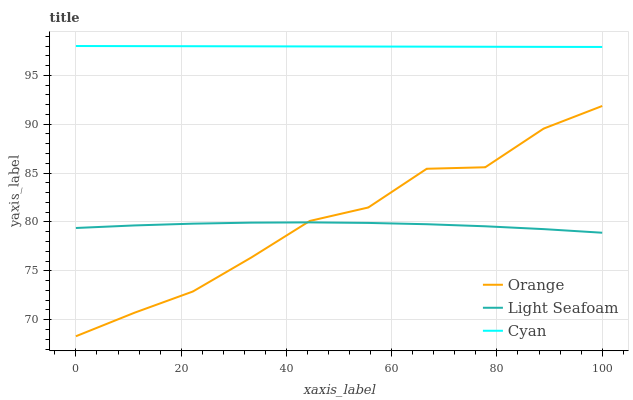Does Light Seafoam have the minimum area under the curve?
Answer yes or no. Yes. Does Cyan have the maximum area under the curve?
Answer yes or no. Yes. Does Cyan have the minimum area under the curve?
Answer yes or no. No. Does Light Seafoam have the maximum area under the curve?
Answer yes or no. No. Is Cyan the smoothest?
Answer yes or no. Yes. Is Orange the roughest?
Answer yes or no. Yes. Is Light Seafoam the smoothest?
Answer yes or no. No. Is Light Seafoam the roughest?
Answer yes or no. No. Does Orange have the lowest value?
Answer yes or no. Yes. Does Light Seafoam have the lowest value?
Answer yes or no. No. Does Cyan have the highest value?
Answer yes or no. Yes. Does Light Seafoam have the highest value?
Answer yes or no. No. Is Light Seafoam less than Cyan?
Answer yes or no. Yes. Is Cyan greater than Light Seafoam?
Answer yes or no. Yes. Does Light Seafoam intersect Orange?
Answer yes or no. Yes. Is Light Seafoam less than Orange?
Answer yes or no. No. Is Light Seafoam greater than Orange?
Answer yes or no. No. Does Light Seafoam intersect Cyan?
Answer yes or no. No. 